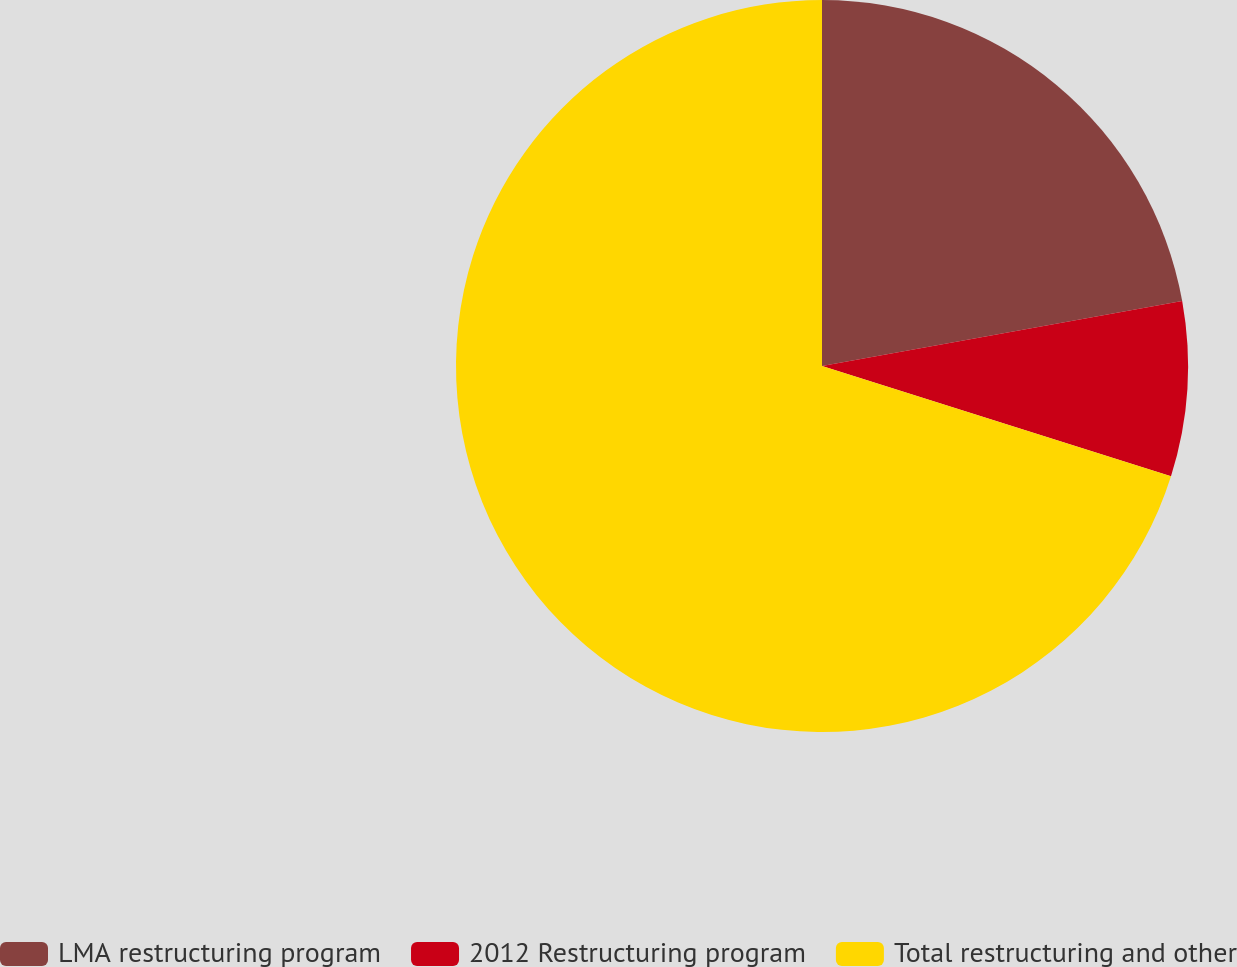Convert chart. <chart><loc_0><loc_0><loc_500><loc_500><pie_chart><fcel>LMA restructuring program<fcel>2012 Restructuring program<fcel>Total restructuring and other<nl><fcel>22.16%<fcel>7.71%<fcel>70.13%<nl></chart> 